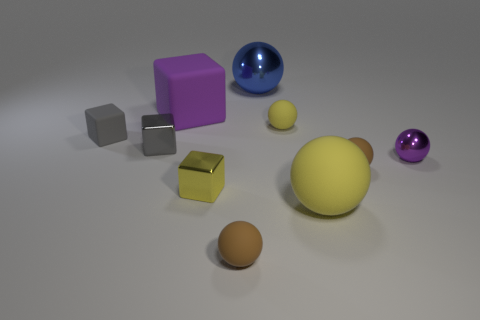Is the purple thing behind the small purple thing made of the same material as the tiny purple sphere?
Ensure brevity in your answer.  No. What number of other things are there of the same color as the large cube?
Offer a very short reply. 1. What number of other things are the same shape as the small purple metal thing?
Ensure brevity in your answer.  5. Does the large object in front of the big purple matte thing have the same shape as the small shiny thing in front of the tiny metallic ball?
Your answer should be very brief. No. Is the number of brown rubber objects on the left side of the purple cube the same as the number of big yellow matte objects in front of the big yellow matte object?
Your answer should be very brief. Yes. What is the shape of the big purple thing that is to the left of the metallic thing behind the big rubber object behind the large yellow rubber ball?
Give a very brief answer. Cube. Are the thing that is behind the purple matte object and the tiny yellow object right of the big blue metallic object made of the same material?
Your response must be concise. No. What is the shape of the big thing in front of the gray metal thing?
Provide a short and direct response. Sphere. Are there fewer big rubber spheres than gray cubes?
Your response must be concise. Yes. There is a large rubber thing behind the tiny matte object left of the big purple matte object; is there a small cube that is right of it?
Your response must be concise. Yes. 